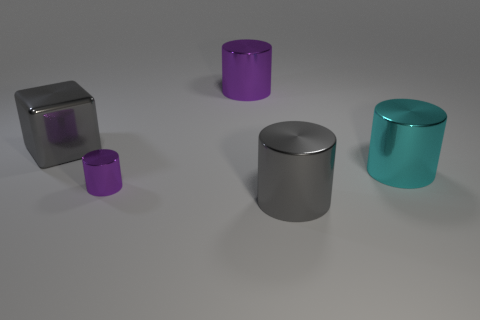How many red objects are either cubes or small cylinders?
Give a very brief answer. 0. How many gray shiny cylinders are the same size as the cyan object?
Give a very brief answer. 1. What shape is the big metal object that is the same color as the small metal thing?
Provide a short and direct response. Cylinder. How many things are purple metal cylinders or big metallic cylinders that are in front of the big metallic block?
Offer a terse response. 4. Does the gray metallic thing behind the small metal object have the same size as the metal cylinder that is in front of the small purple metal thing?
Offer a terse response. Yes. How many gray shiny objects have the same shape as the large cyan object?
Ensure brevity in your answer.  1. There is a purple object that is made of the same material as the small purple cylinder; what shape is it?
Your answer should be very brief. Cylinder. The cylinder on the right side of the large shiny thing in front of the purple metallic thing on the left side of the large purple cylinder is made of what material?
Give a very brief answer. Metal. Is the size of the cyan object the same as the shiny cylinder behind the metallic cube?
Your answer should be very brief. Yes. There is another gray thing that is the same shape as the small thing; what material is it?
Give a very brief answer. Metal. 